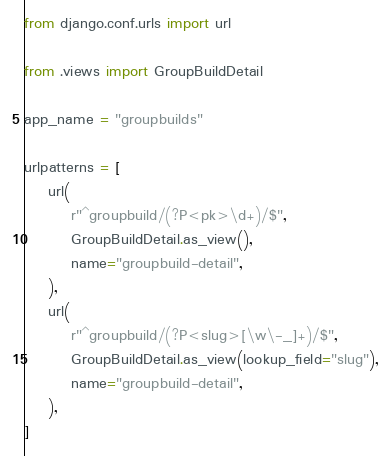<code> <loc_0><loc_0><loc_500><loc_500><_Python_>from django.conf.urls import url

from .views import GroupBuildDetail

app_name = "groupbuilds"

urlpatterns = [
    url(
        r"^groupbuild/(?P<pk>\d+)/$",
        GroupBuildDetail.as_view(),
        name="groupbuild-detail",
    ),
    url(
        r"^groupbuild/(?P<slug>[\w\-_]+)/$",
        GroupBuildDetail.as_view(lookup_field="slug"),
        name="groupbuild-detail",
    ),
]
</code> 